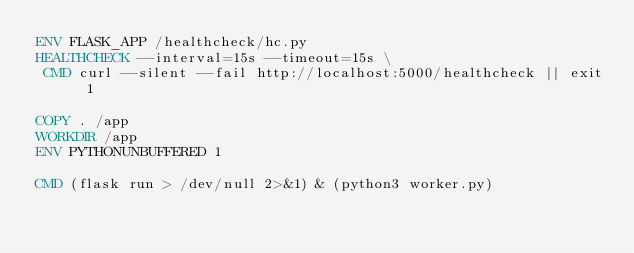Convert code to text. <code><loc_0><loc_0><loc_500><loc_500><_Dockerfile_>ENV FLASK_APP /healthcheck/hc.py
HEALTHCHECK --interval=15s --timeout=15s \
 CMD curl --silent --fail http://localhost:5000/healthcheck || exit 1

COPY . /app
WORKDIR /app
ENV PYTHONUNBUFFERED 1

CMD (flask run > /dev/null 2>&1) & (python3 worker.py)
</code> 